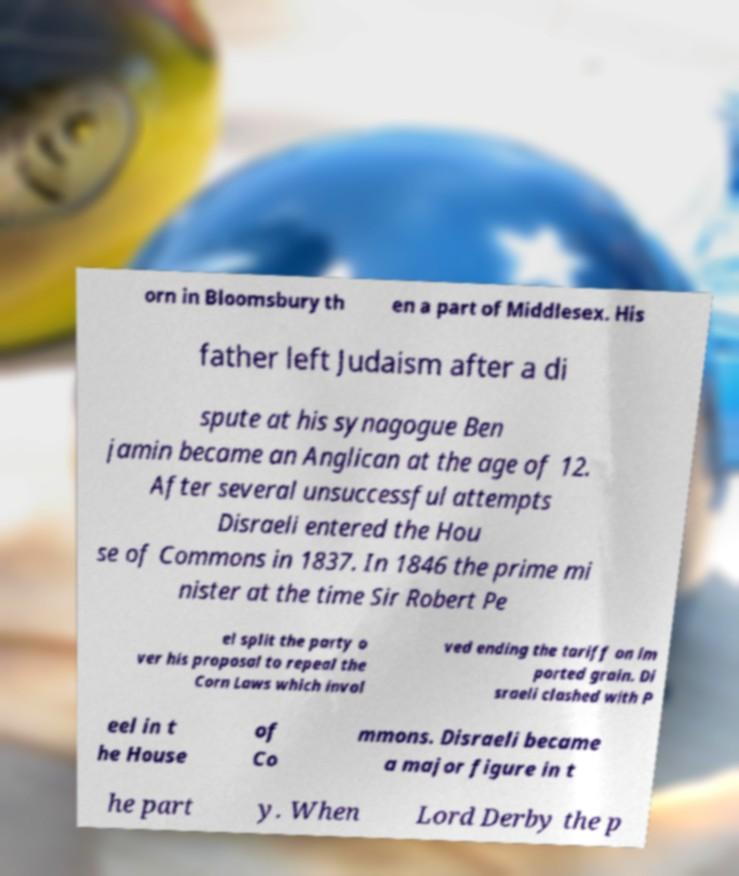Please identify and transcribe the text found in this image. orn in Bloomsbury th en a part of Middlesex. His father left Judaism after a di spute at his synagogue Ben jamin became an Anglican at the age of 12. After several unsuccessful attempts Disraeli entered the Hou se of Commons in 1837. In 1846 the prime mi nister at the time Sir Robert Pe el split the party o ver his proposal to repeal the Corn Laws which invol ved ending the tariff on im ported grain. Di sraeli clashed with P eel in t he House of Co mmons. Disraeli became a major figure in t he part y. When Lord Derby the p 